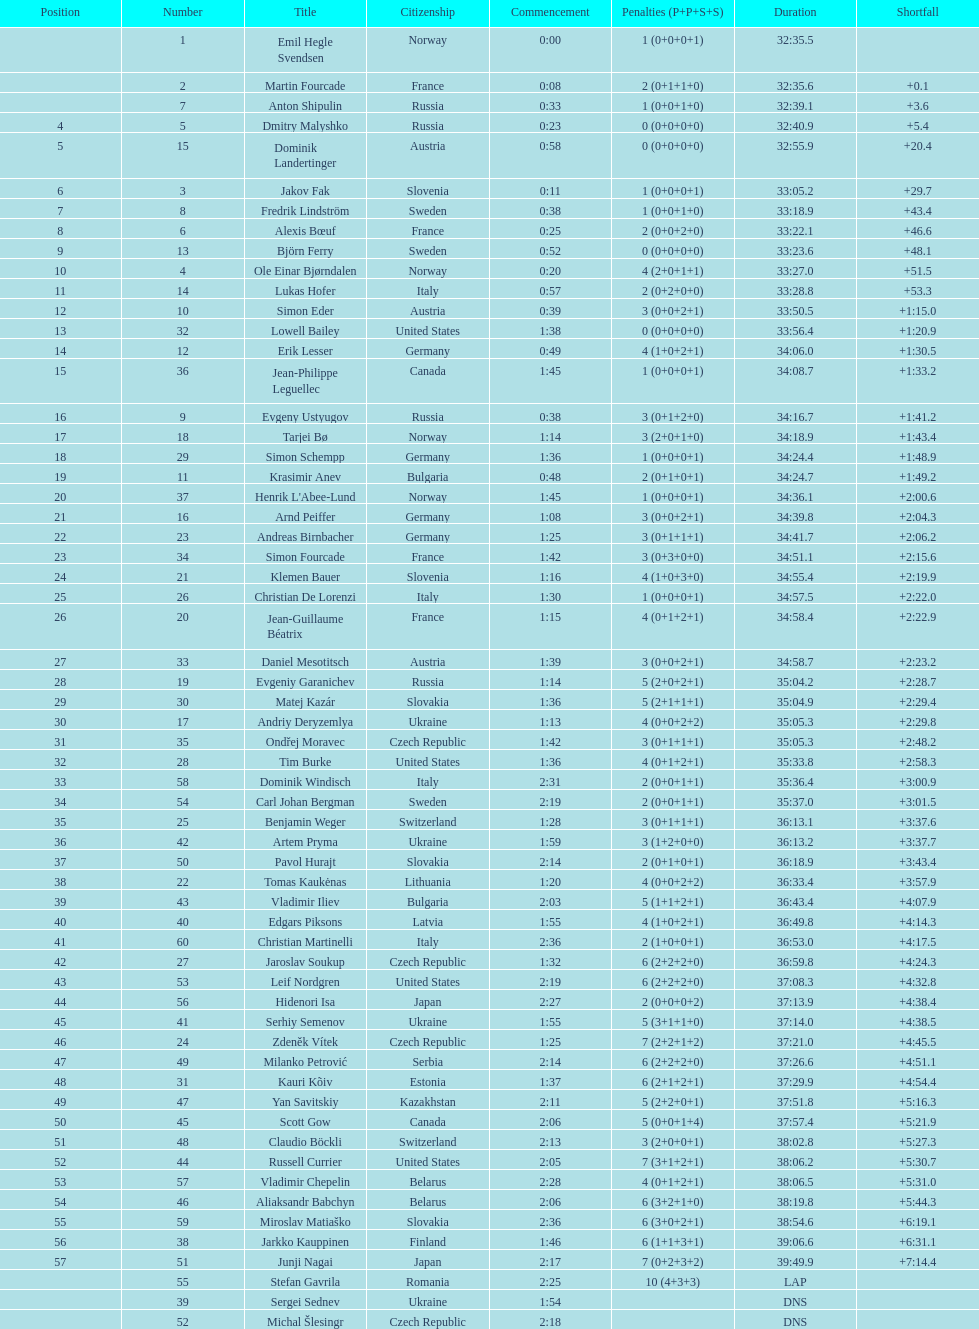How many penalties did germany get all together? 11. 